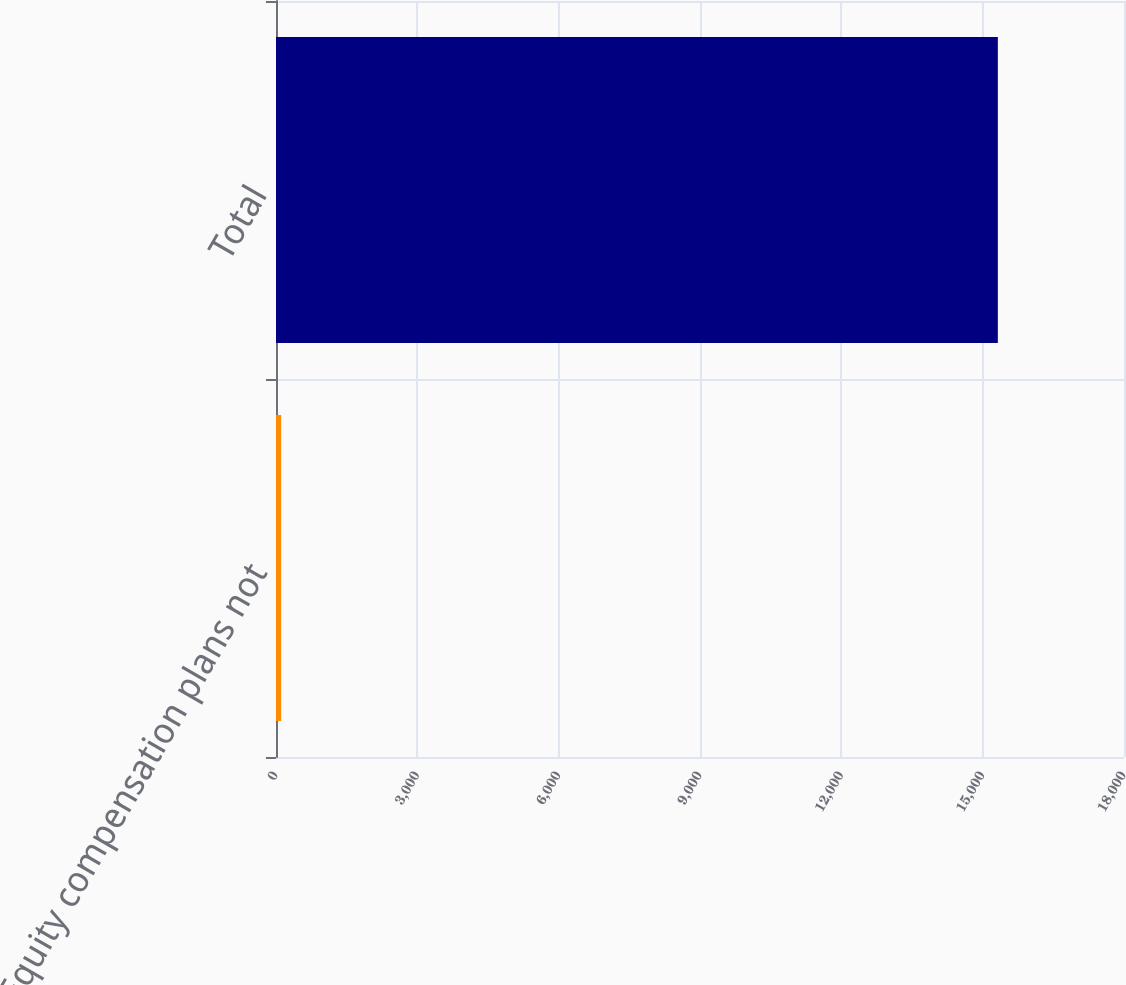Convert chart to OTSL. <chart><loc_0><loc_0><loc_500><loc_500><bar_chart><fcel>Equity compensation plans not<fcel>Total<nl><fcel>109<fcel>15322<nl></chart> 